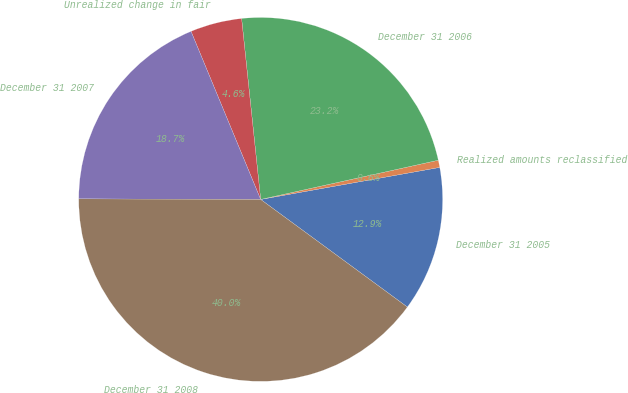<chart> <loc_0><loc_0><loc_500><loc_500><pie_chart><fcel>December 31 2005<fcel>Realized amounts reclassified<fcel>December 31 2006<fcel>Unrealized change in fair<fcel>December 31 2007<fcel>December 31 2008<nl><fcel>12.89%<fcel>0.64%<fcel>23.21%<fcel>4.58%<fcel>18.7%<fcel>39.97%<nl></chart> 